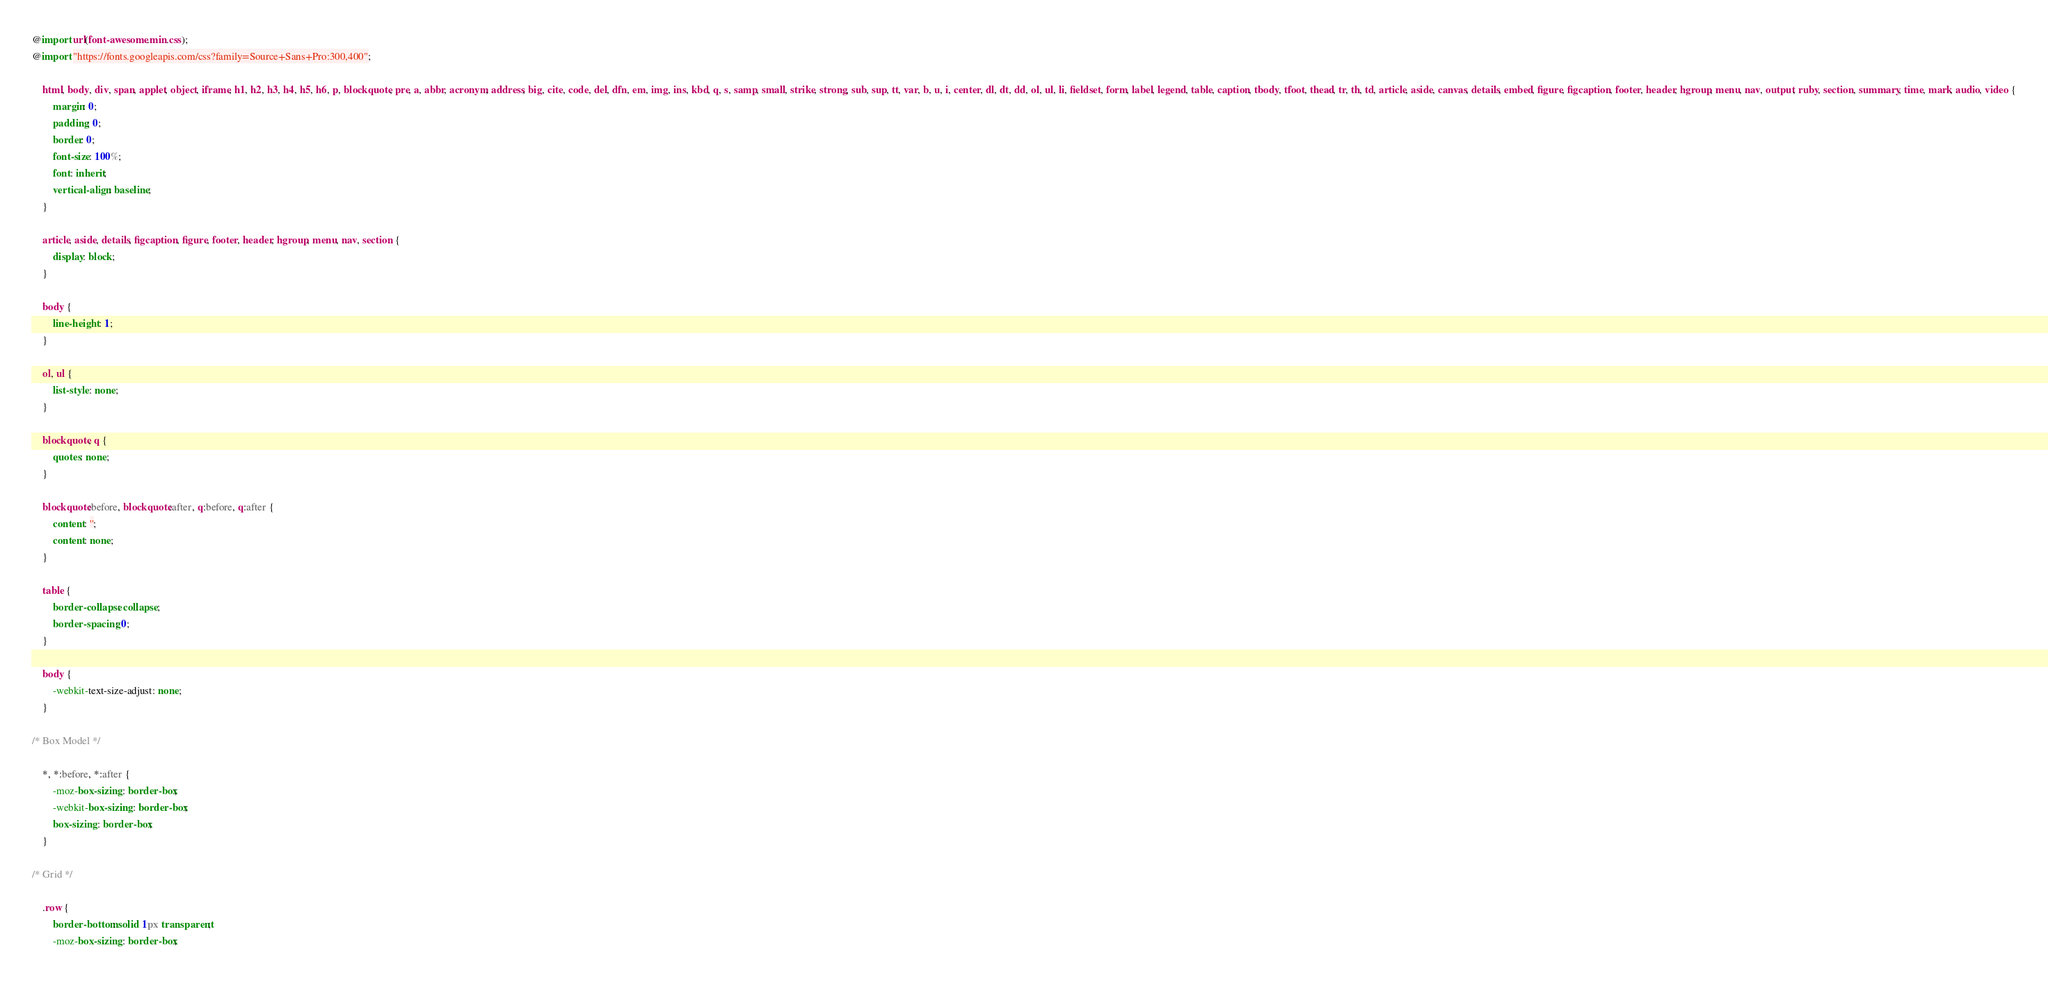Convert code to text. <code><loc_0><loc_0><loc_500><loc_500><_CSS_>@import url(font-awesome.min.css);
@import "https://fonts.googleapis.com/css?family=Source+Sans+Pro:300,400";

	html, body, div, span, applet, object, iframe, h1, h2, h3, h4, h5, h6, p, blockquote, pre, a, abbr, acronym, address, big, cite, code, del, dfn, em, img, ins, kbd, q, s, samp, small, strike, strong, sub, sup, tt, var, b, u, i, center, dl, dt, dd, ol, ul, li, fieldset, form, label, legend, table, caption, tbody, tfoot, thead, tr, th, td, article, aside, canvas, details, embed, figure, figcaption, footer, header, hgroup, menu, nav, output, ruby, section, summary, time, mark, audio, video {
		margin: 0;
		padding: 0;
		border: 0;
		font-size: 100%;
		font: inherit;
		vertical-align: baseline;
	}

	article, aside, details, figcaption, figure, footer, header, hgroup, menu, nav, section {
		display: block;
	}

	body {
		line-height: 1;
	}

	ol, ul {
		list-style: none;
	}

	blockquote, q {
		quotes: none;
	}

	blockquote:before, blockquote:after, q:before, q:after {
		content: '';
		content: none;
	}

	table {
		border-collapse: collapse;
		border-spacing: 0;
	}

	body {
		-webkit-text-size-adjust: none;
	}

/* Box Model */

	*, *:before, *:after {
		-moz-box-sizing: border-box;
		-webkit-box-sizing: border-box;
		box-sizing: border-box;
	}

/* Grid */

	.row {
		border-bottom: solid 1px transparent;
		-moz-box-sizing: border-box;</code> 